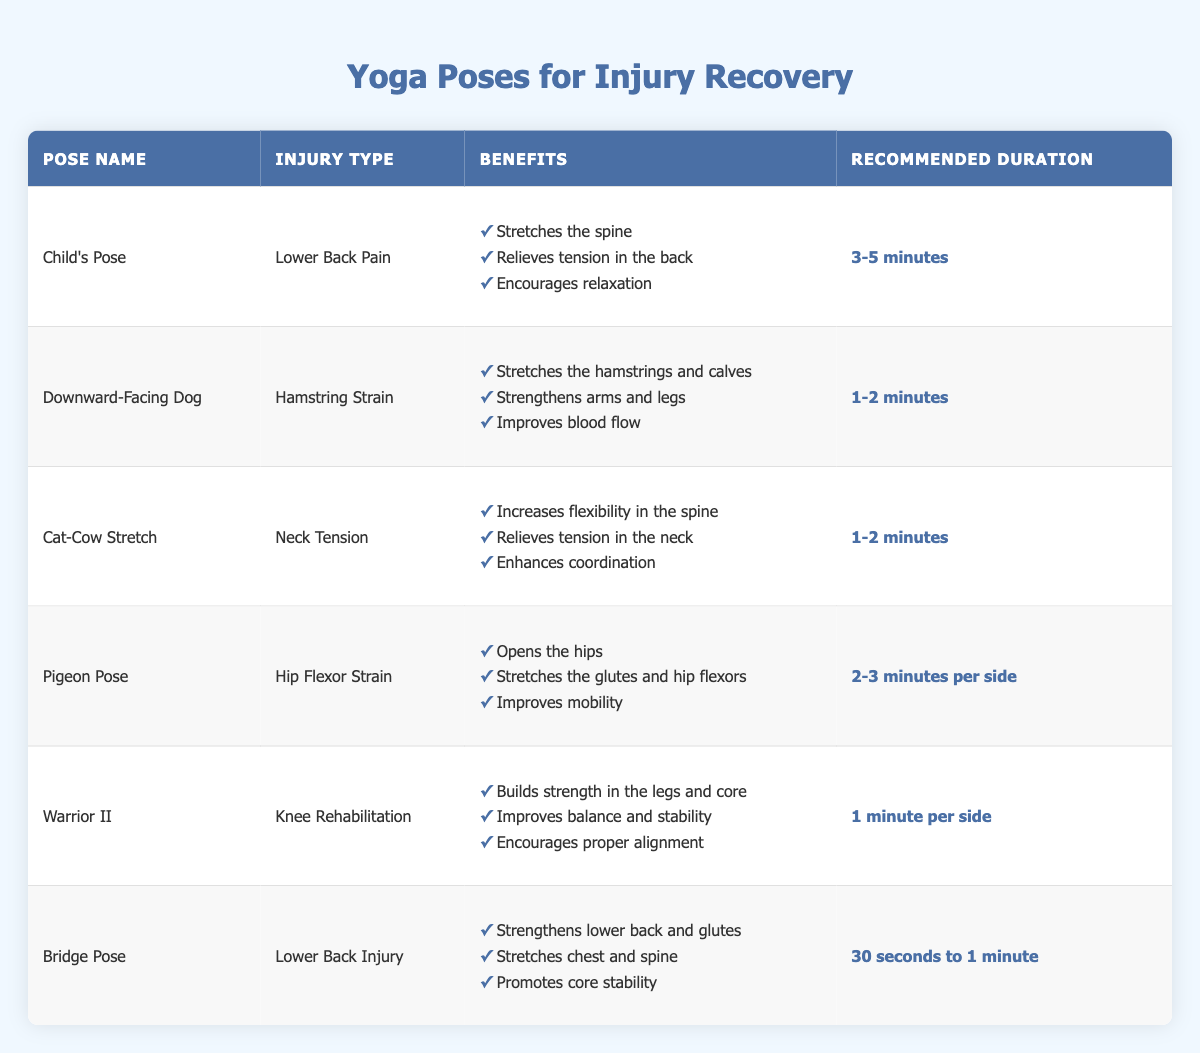What is the recommended duration for the Child's Pose? The table lists the recommended duration for the Child's Pose as "3-5 minutes."
Answer: 3-5 minutes Which pose is recommended for hip flexor strain? According to the table, Pigeon Pose is recommended for injury related to hip flexor strain.
Answer: Pigeon Pose Do both the Downward-Facing Dog and Cat-Cow Stretch target neck tension? The Downward-Facing Dog is associated with hamstring strain, while the Cat-Cow Stretch is specifically for neck tension, confirming that only the Cat-Cow Stretch targets that area.
Answer: No What benefits are associated with the Warrior II pose? The Warrior II pose provides three benefits: building strength in the legs and core, improving balance and stability, and encouraging proper alignment as detailed in the table.
Answer: Strengthens legs and core, improves balance, encourages alignment If you practice the Pigeon Pose for 3 minutes on each side, how long will the total practice time be? The recommended duration for Pigeon Pose is "2-3 minutes per side." If you practice for 3 minutes on each side, that totals to 6 minutes (3 minutes + 3 minutes).
Answer: 6 minutes Which yoga pose offers benefits for lower back pain? The Child's Pose specifically targets lower back pain, providing significant benefits as outlined in the table.
Answer: Child's Pose Is there a yoga pose that recommends a duration of 30 seconds to 1 minute? Yes, the Bridge Pose recommends a duration of 30 seconds to 1 minute as per the table.
Answer: Yes What is the total number of benefits listed for the Bridge Pose and the Pigeon Pose combined? The Bridge Pose has 3 benefits and the Pigeon Pose also presents 3 benefits, leading to a total of 3 + 3 = 6 benefits when combined.
Answer: 6 benefits 